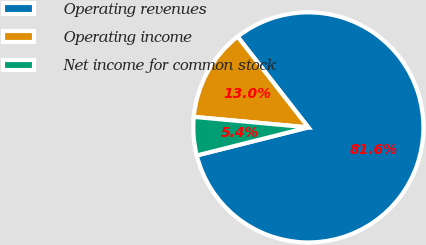Convert chart to OTSL. <chart><loc_0><loc_0><loc_500><loc_500><pie_chart><fcel>Operating revenues<fcel>Operating income<fcel>Net income for common stock<nl><fcel>81.62%<fcel>13.0%<fcel>5.38%<nl></chart> 